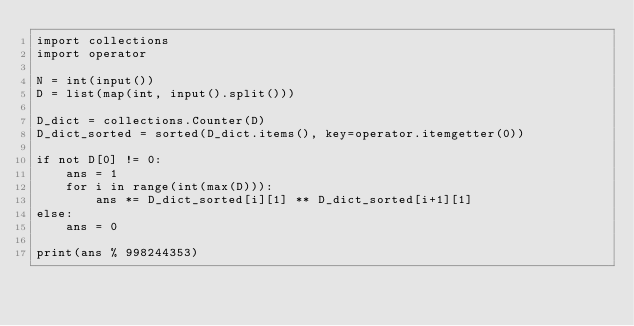<code> <loc_0><loc_0><loc_500><loc_500><_Python_>import collections
import operator

N = int(input())
D = list(map(int, input().split()))

D_dict = collections.Counter(D)
D_dict_sorted = sorted(D_dict.items(), key=operator.itemgetter(0))

if not D[0] != 0:
    ans = 1
    for i in range(int(max(D))):
        ans *= D_dict_sorted[i][1] ** D_dict_sorted[i+1][1]
else:
    ans = 0

print(ans % 998244353)</code> 